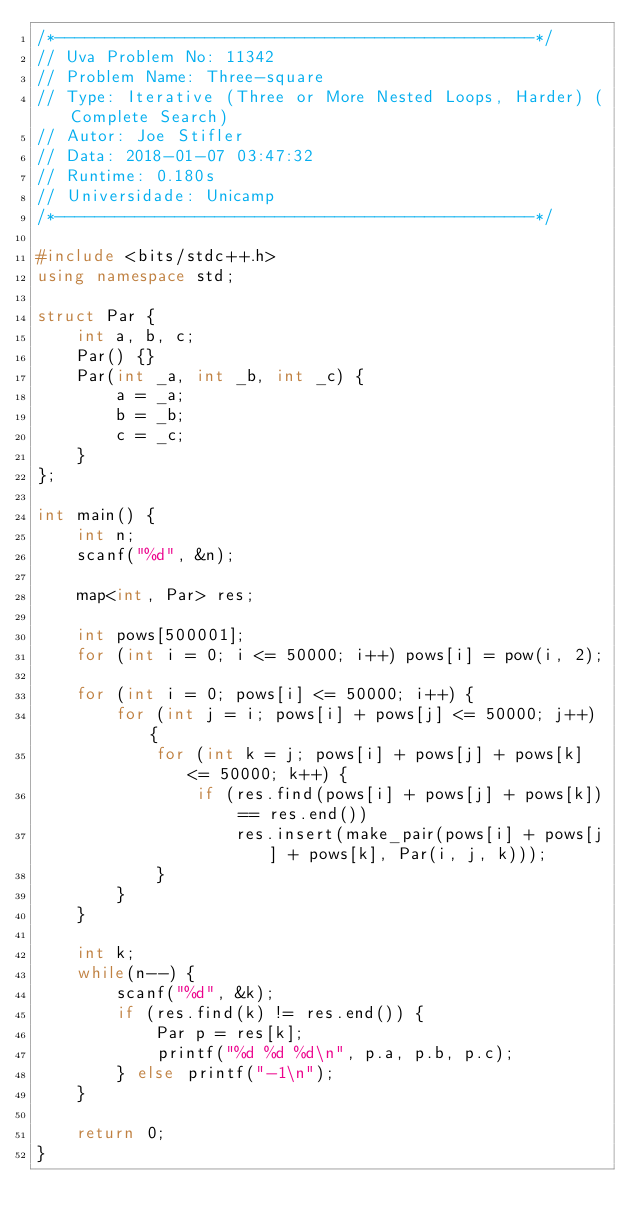Convert code to text. <code><loc_0><loc_0><loc_500><loc_500><_C++_>/*------------------------------------------------*/
// Uva Problem No: 11342
// Problem Name: Three-square
// Type: Iterative (Three or More Nested Loops, Harder) (Complete Search)
// Autor: Joe Stifler
// Data: 2018-01-07 03:47:32
// Runtime: 0.180s
// Universidade: Unicamp
/*------------------------------------------------*/

#include <bits/stdc++.h>
using namespace std;

struct Par {
    int a, b, c;
    Par() {}
    Par(int _a, int _b, int _c) {
        a = _a;
        b = _b;
        c = _c;
    }
};

int main() {
    int n;
    scanf("%d", &n);

    map<int, Par> res;

    int pows[500001];
    for (int i = 0; i <= 50000; i++) pows[i] = pow(i, 2);

    for (int i = 0; pows[i] <= 50000; i++) {
        for (int j = i; pows[i] + pows[j] <= 50000; j++) {
            for (int k = j; pows[i] + pows[j] + pows[k] <= 50000; k++) {
                if (res.find(pows[i] + pows[j] + pows[k]) == res.end())
                    res.insert(make_pair(pows[i] + pows[j] + pows[k], Par(i, j, k)));
            }
        }
    }

    int k;
    while(n--) {
        scanf("%d", &k);
        if (res.find(k) != res.end()) {
            Par p = res[k];
            printf("%d %d %d\n", p.a, p.b, p.c);
        } else printf("-1\n");
    }

    return 0;
}
</code> 